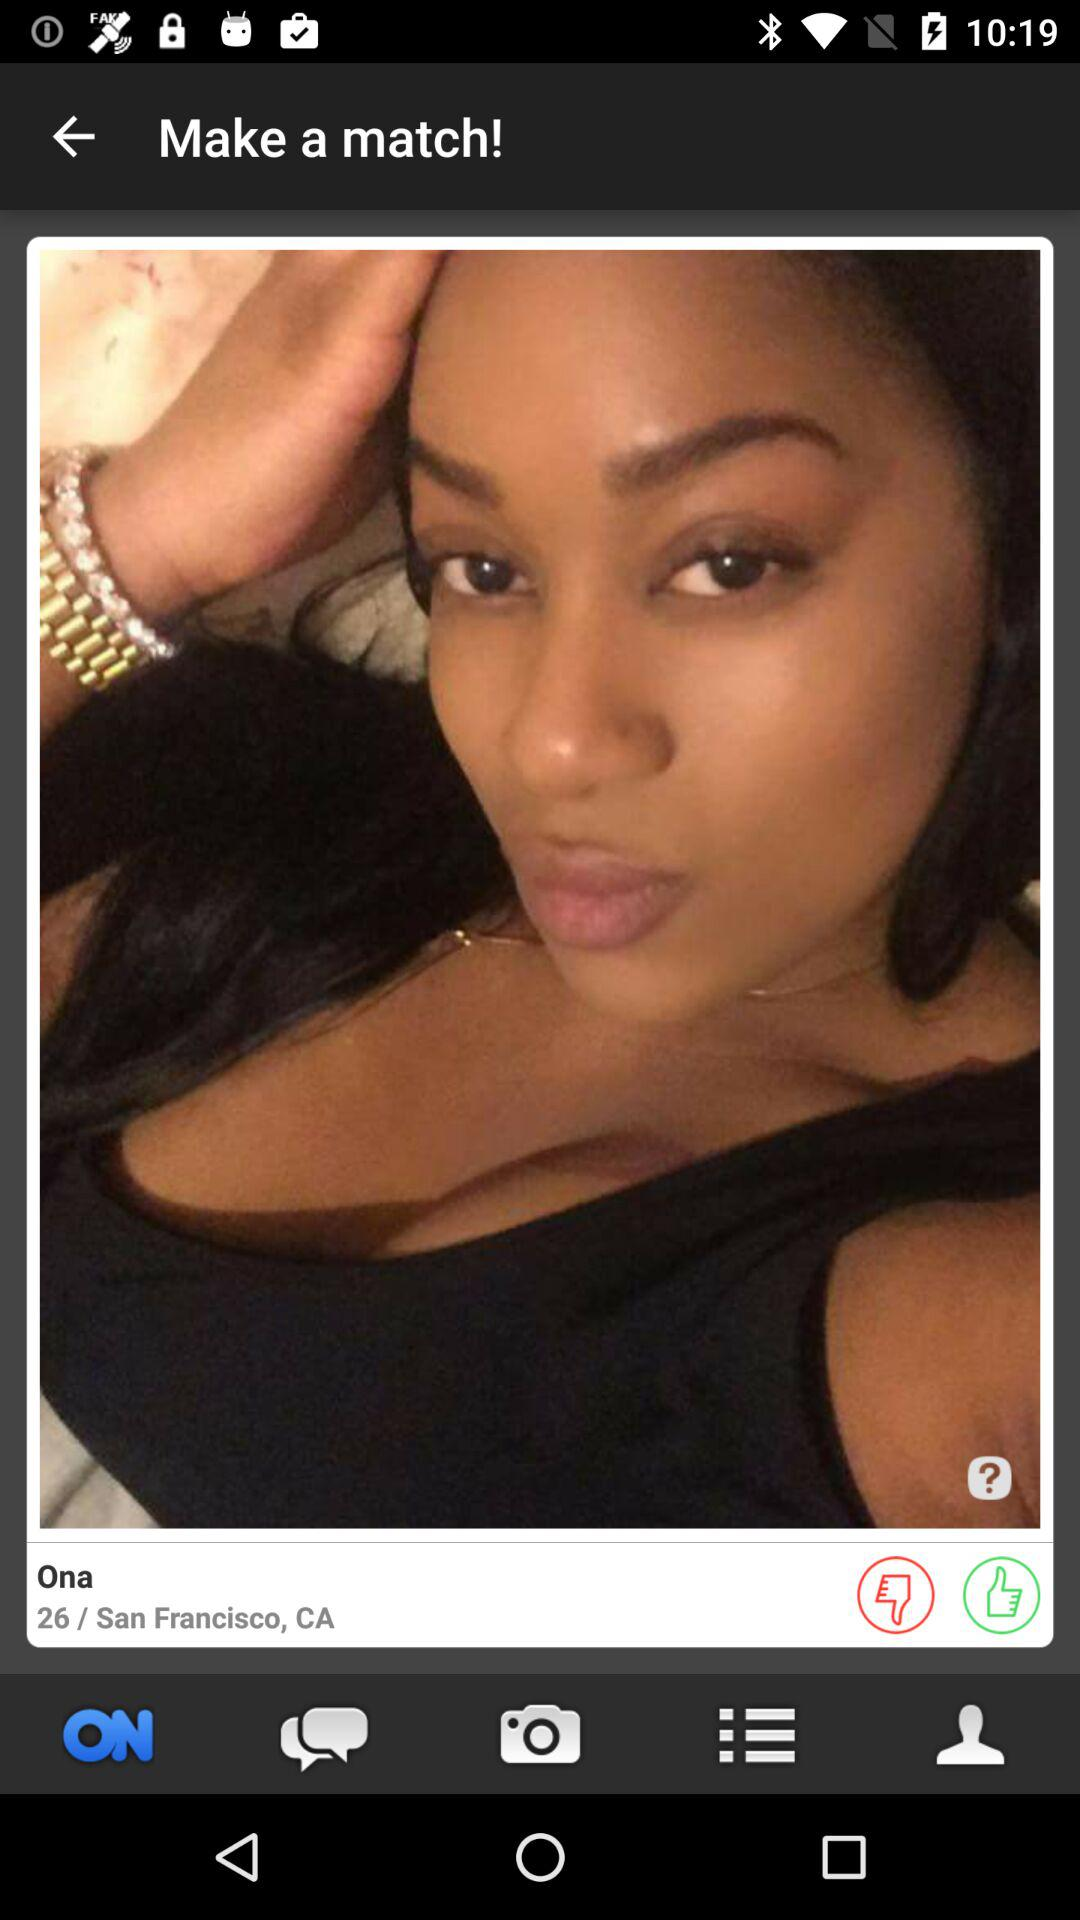What is the age of Ona? The age of Ona is 26 years old. 